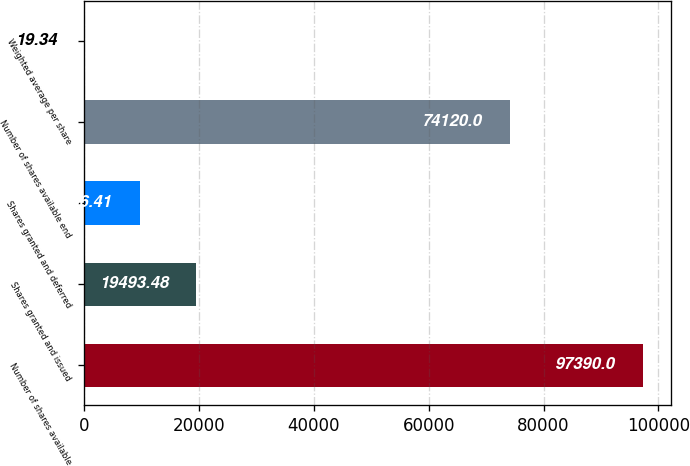Convert chart to OTSL. <chart><loc_0><loc_0><loc_500><loc_500><bar_chart><fcel>Number of shares available<fcel>Shares granted and issued<fcel>Shares granted and deferred<fcel>Number of shares available end<fcel>Weighted average per share<nl><fcel>97390<fcel>19493.5<fcel>9756.41<fcel>74120<fcel>19.34<nl></chart> 